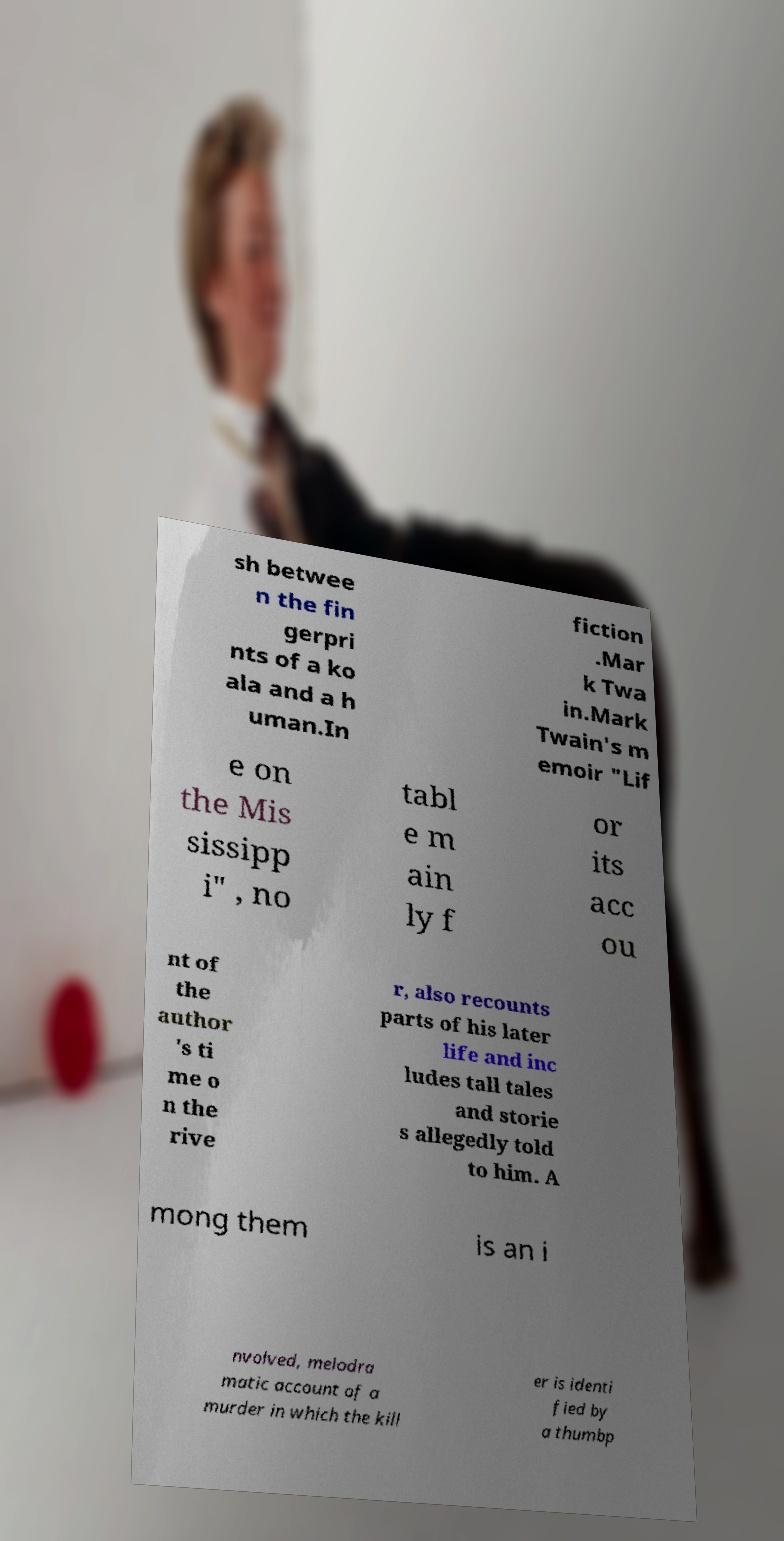Could you extract and type out the text from this image? sh betwee n the fin gerpri nts of a ko ala and a h uman.In fiction .Mar k Twa in.Mark Twain's m emoir "Lif e on the Mis sissipp i" , no tabl e m ain ly f or its acc ou nt of the author 's ti me o n the rive r, also recounts parts of his later life and inc ludes tall tales and storie s allegedly told to him. A mong them is an i nvolved, melodra matic account of a murder in which the kill er is identi fied by a thumbp 